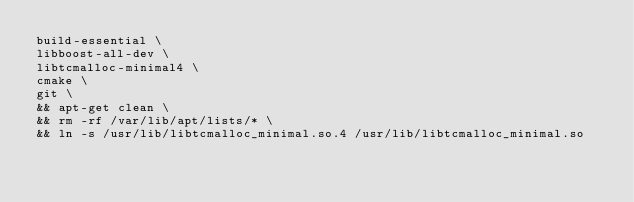<code> <loc_0><loc_0><loc_500><loc_500><_Dockerfile_>build-essential \
libboost-all-dev \
libtcmalloc-minimal4 \
cmake \
git \
&& apt-get clean \
&& rm -rf /var/lib/apt/lists/* \
&& ln -s /usr/lib/libtcmalloc_minimal.so.4 /usr/lib/libtcmalloc_minimal.so
</code> 